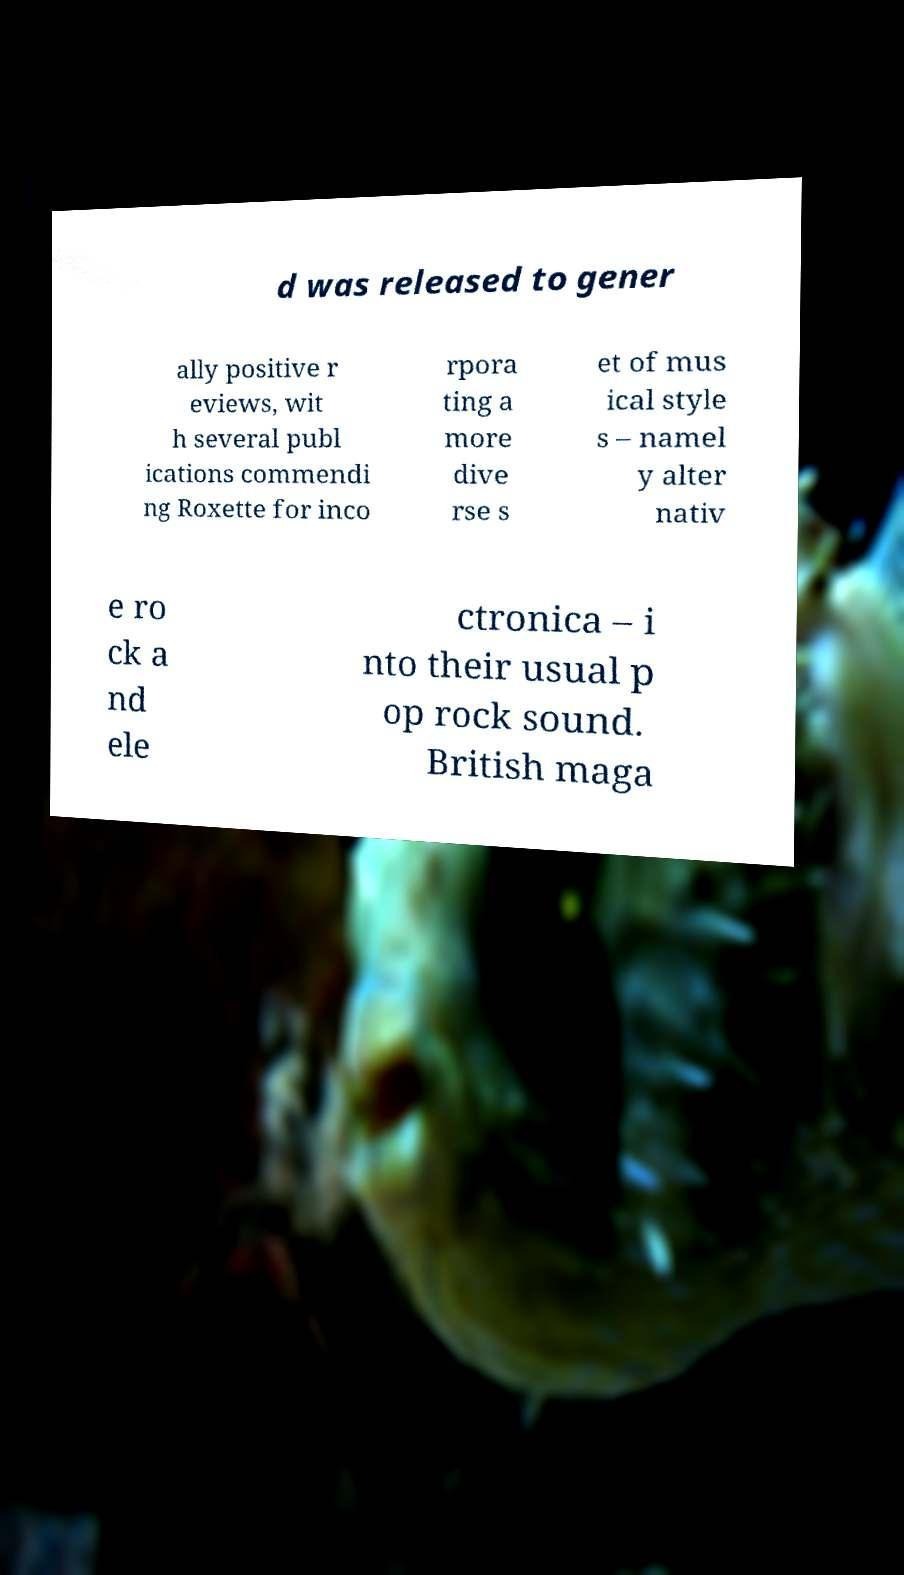Could you assist in decoding the text presented in this image and type it out clearly? d was released to gener ally positive r eviews, wit h several publ ications commendi ng Roxette for inco rpora ting a more dive rse s et of mus ical style s – namel y alter nativ e ro ck a nd ele ctronica – i nto their usual p op rock sound. British maga 